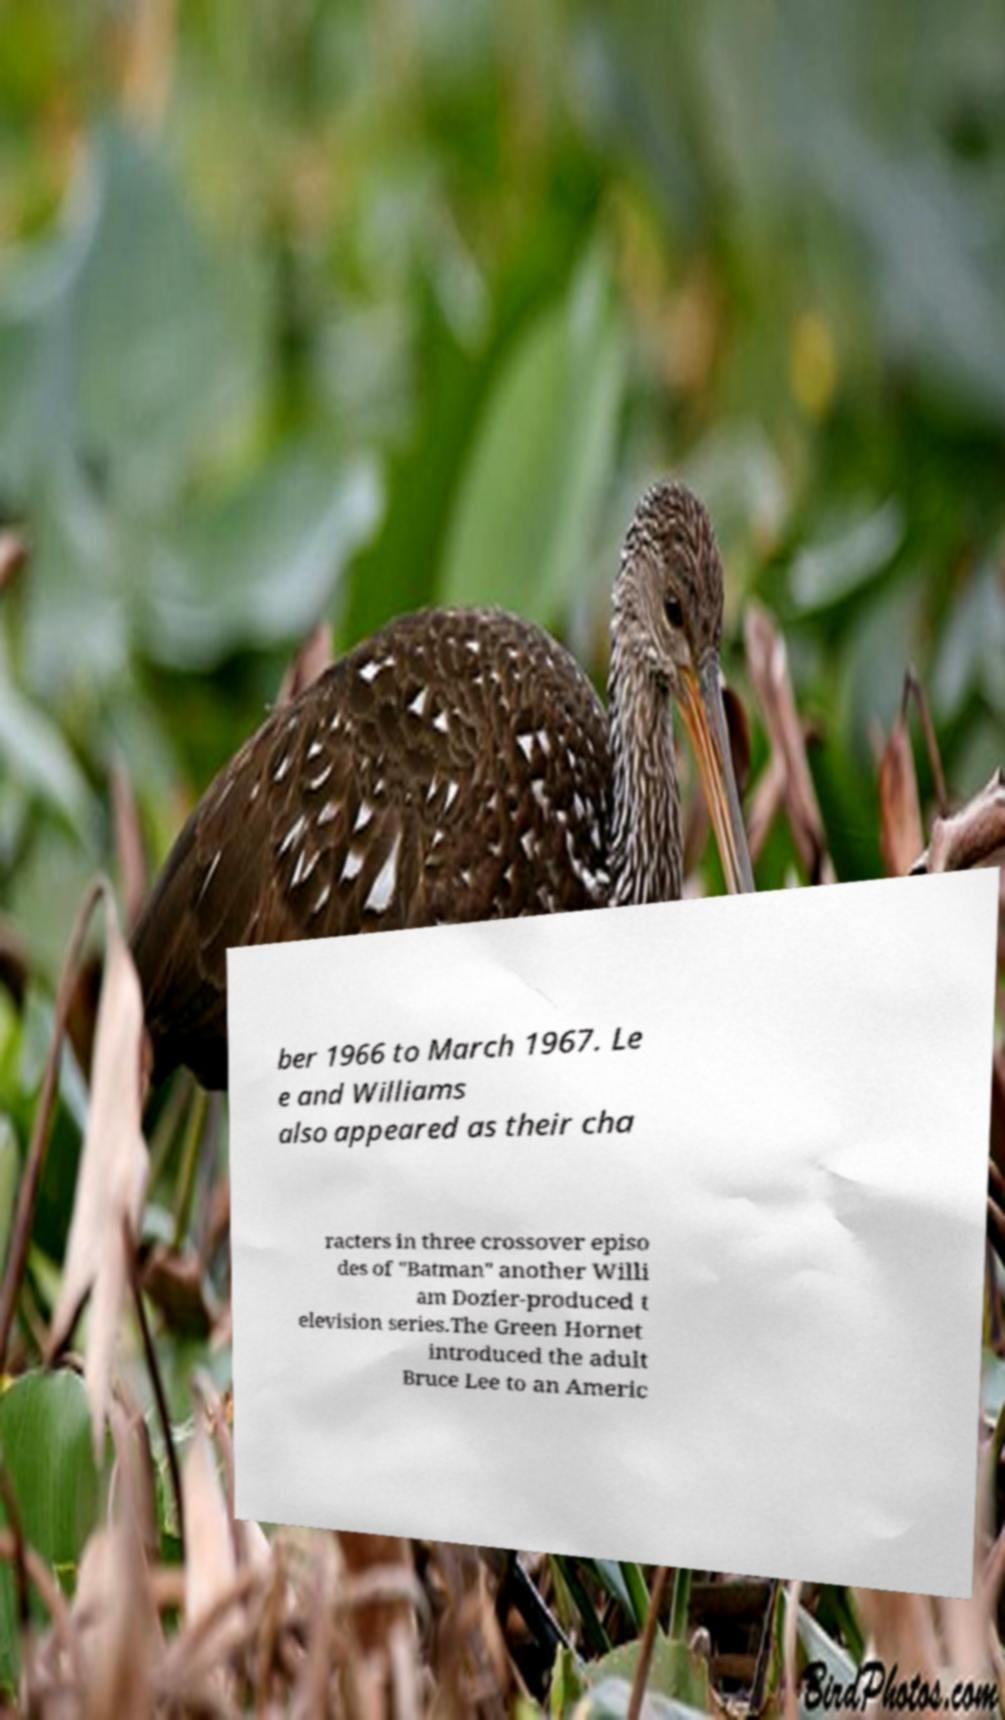Can you accurately transcribe the text from the provided image for me? ber 1966 to March 1967. Le e and Williams also appeared as their cha racters in three crossover episo des of "Batman" another Willi am Dozier-produced t elevision series.The Green Hornet introduced the adult Bruce Lee to an Americ 